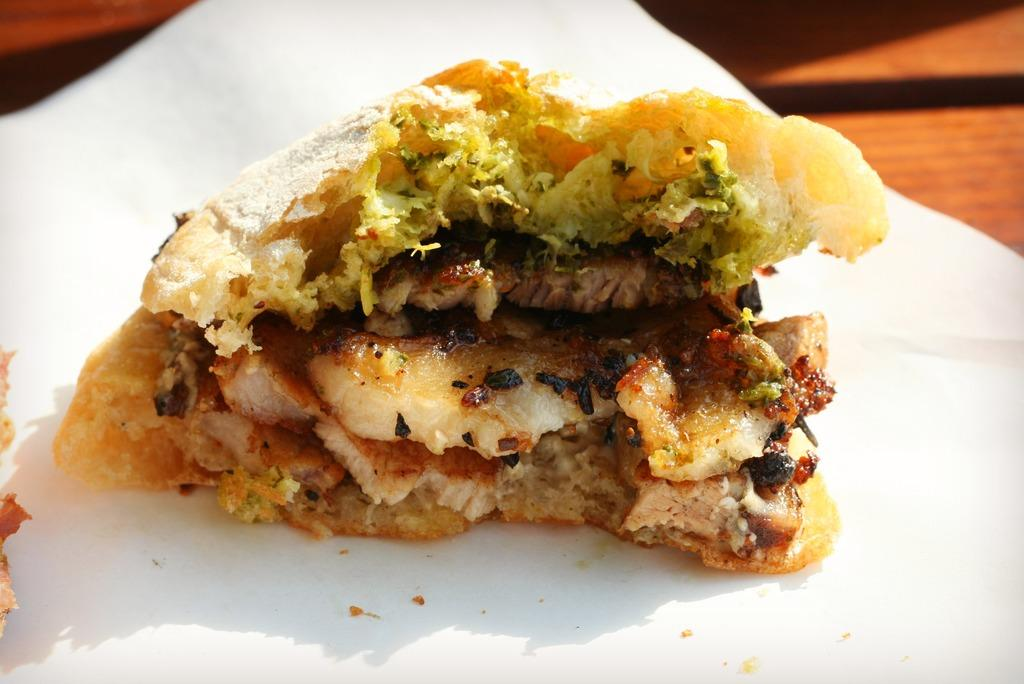What is present in the image? There is food in the image. How is the food arranged or presented? The food is placed on a white paper. What type of gate can be seen in the image? There is no gate present in the image; it only features food placed on a white paper. 